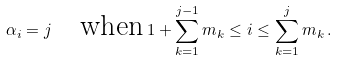<formula> <loc_0><loc_0><loc_500><loc_500>\alpha _ { i } = j \quad \text {when} \, 1 + \sum _ { k = 1 } ^ { j - 1 } m _ { k } \leq i \leq \sum _ { k = 1 } ^ { j } m _ { k } \, .</formula> 